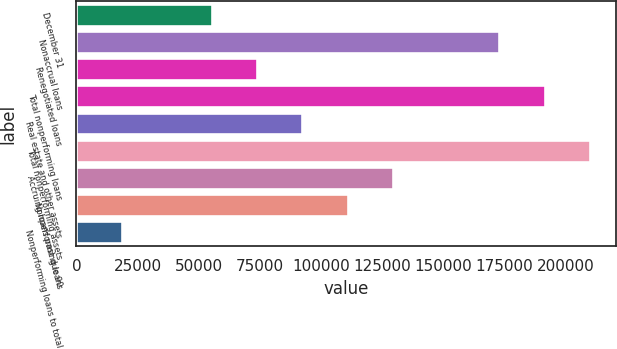<chart> <loc_0><loc_0><loc_500><loc_500><bar_chart><fcel>December 31<fcel>Nonaccrual loans<fcel>Renegotiated loans<fcel>Total nonperforming loans<fcel>Real estate and other assets<fcel>Total nonperforming assets<fcel>Accruing loans past due 90<fcel>Nonperforming loans<fcel>Nonperforming loans to total<nl><fcel>55486.5<fcel>173085<fcel>73981.8<fcel>191581<fcel>92477.2<fcel>210076<fcel>129468<fcel>110973<fcel>18495.8<nl></chart> 